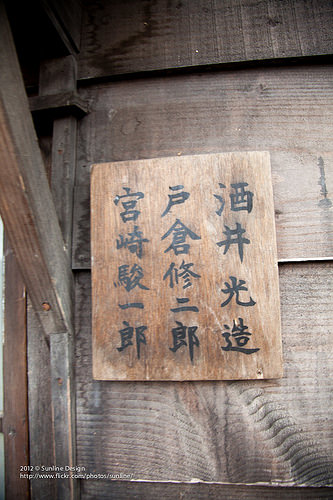<image>
Is the artwork to the right of the nail? Yes. From this viewpoint, the artwork is positioned to the right side relative to the nail. 